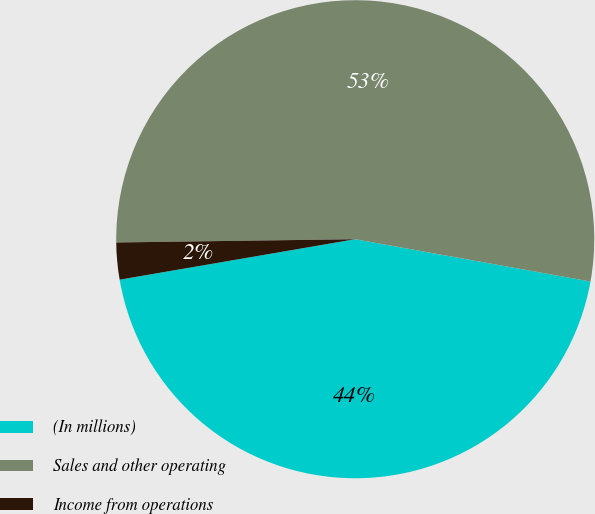Convert chart to OTSL. <chart><loc_0><loc_0><loc_500><loc_500><pie_chart><fcel>(In millions)<fcel>Sales and other operating<fcel>Income from operations<nl><fcel>44.46%<fcel>53.05%<fcel>2.49%<nl></chart> 